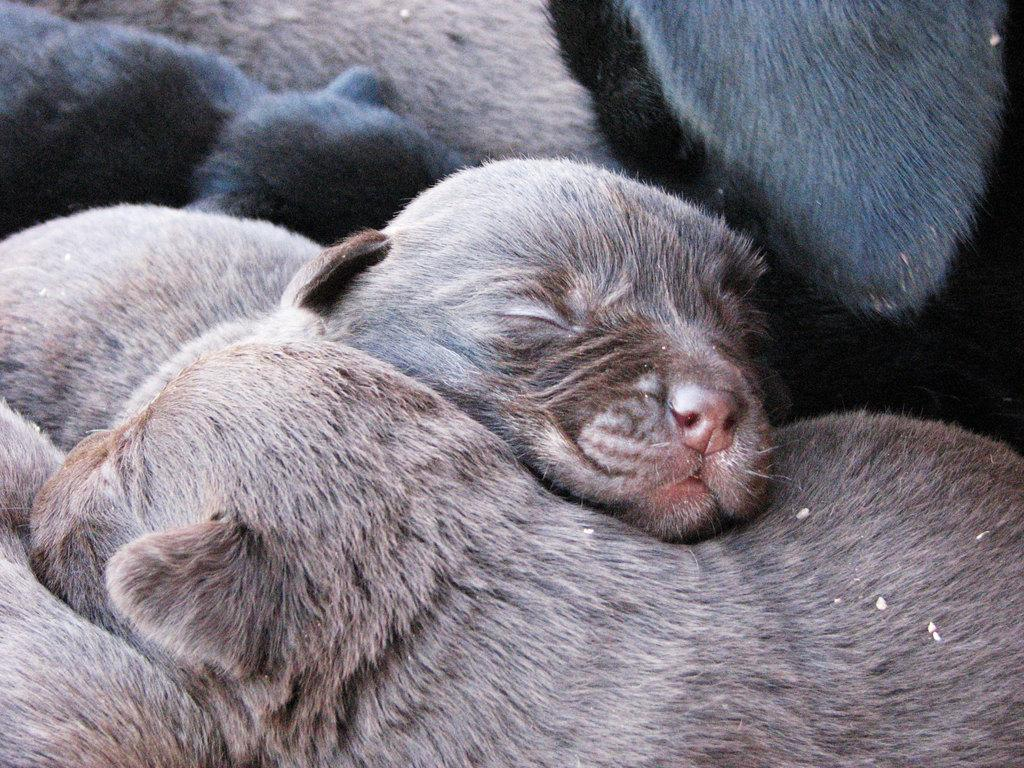What types of living organisms are present in the image? There is a group of animals in the image. What type of wilderness can be seen in the background of the image? There is no wilderness visible in the image, as the fact only mentions a group of animals. 